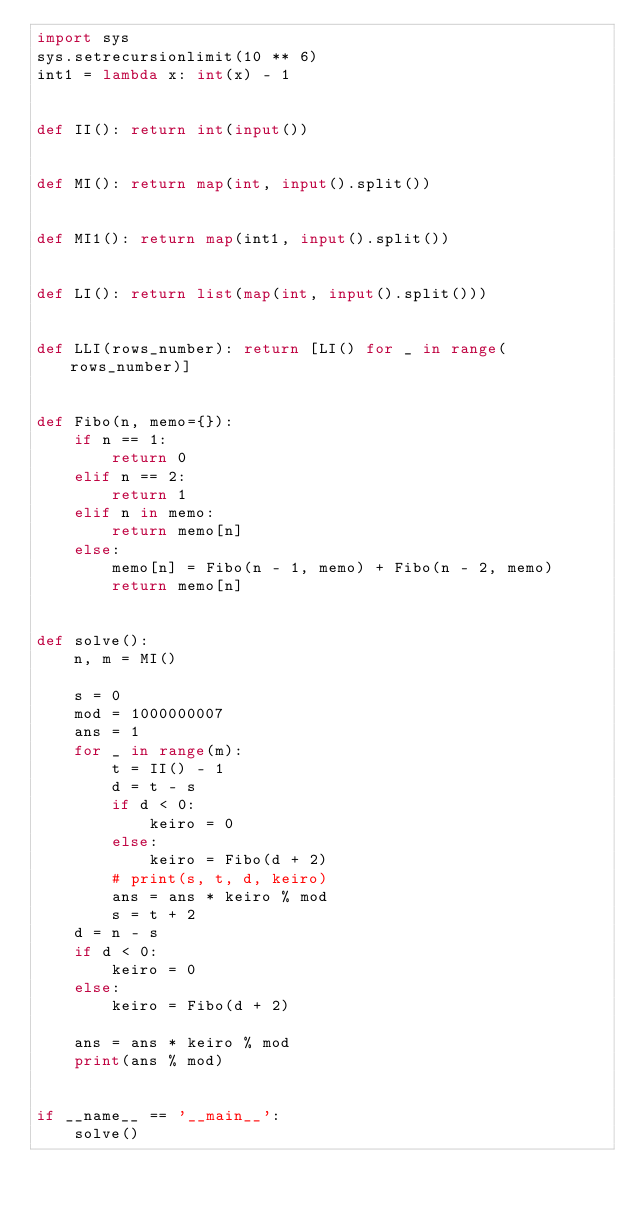<code> <loc_0><loc_0><loc_500><loc_500><_Python_>import sys
sys.setrecursionlimit(10 ** 6)
int1 = lambda x: int(x) - 1


def II(): return int(input())


def MI(): return map(int, input().split())


def MI1(): return map(int1, input().split())


def LI(): return list(map(int, input().split()))


def LLI(rows_number): return [LI() for _ in range(rows_number)]


def Fibo(n, memo={}):
    if n == 1:
        return 0
    elif n == 2:
        return 1
    elif n in memo:
        return memo[n]
    else:
        memo[n] = Fibo(n - 1, memo) + Fibo(n - 2, memo)
        return memo[n]


def solve():
    n, m = MI()

    s = 0
    mod = 1000000007
    ans = 1
    for _ in range(m):
        t = II() - 1
        d = t - s
        if d < 0:
            keiro = 0
        else:
            keiro = Fibo(d + 2)
        # print(s, t, d, keiro)
        ans = ans * keiro % mod
        s = t + 2
    d = n - s
    if d < 0:
        keiro = 0
    else:
        keiro = Fibo(d + 2)

    ans = ans * keiro % mod
    print(ans % mod)


if __name__ == '__main__':
    solve()
</code> 